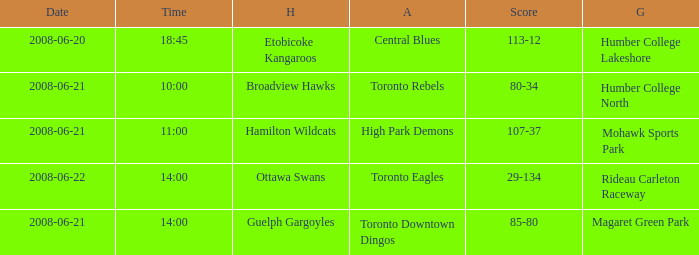What is the Away with a Ground that is humber college north? Toronto Rebels. 